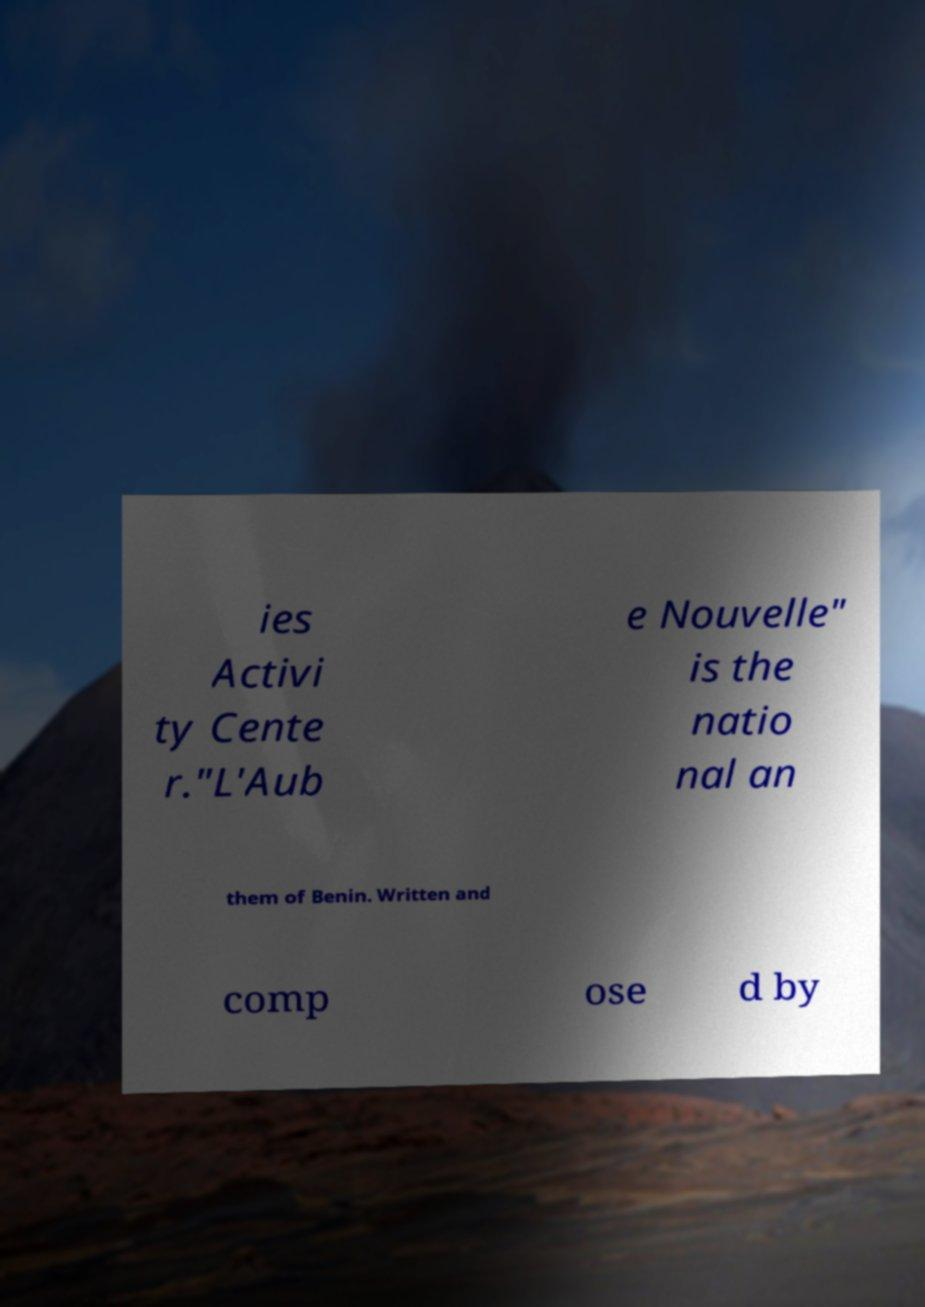I need the written content from this picture converted into text. Can you do that? ies Activi ty Cente r."L'Aub e Nouvelle" is the natio nal an them of Benin. Written and comp ose d by 